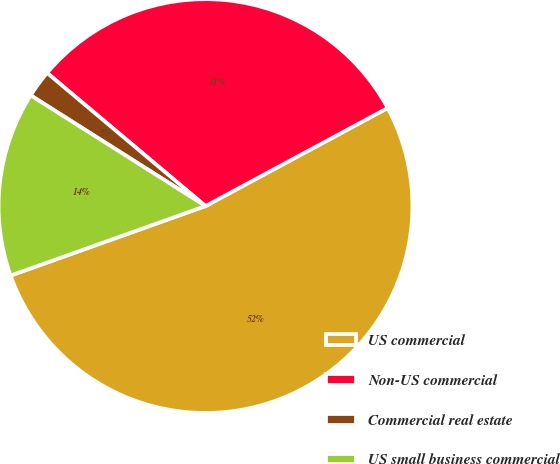Convert chart to OTSL. <chart><loc_0><loc_0><loc_500><loc_500><pie_chart><fcel>US commercial<fcel>Non-US commercial<fcel>Commercial real estate<fcel>US small business commercial<nl><fcel>52.41%<fcel>31.02%<fcel>2.14%<fcel>14.44%<nl></chart> 